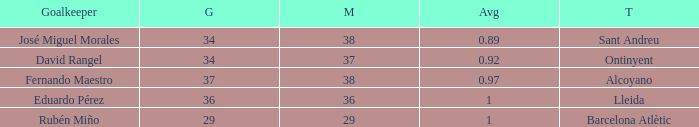What is the sum of Goals, when Matches is less than 29? None. 